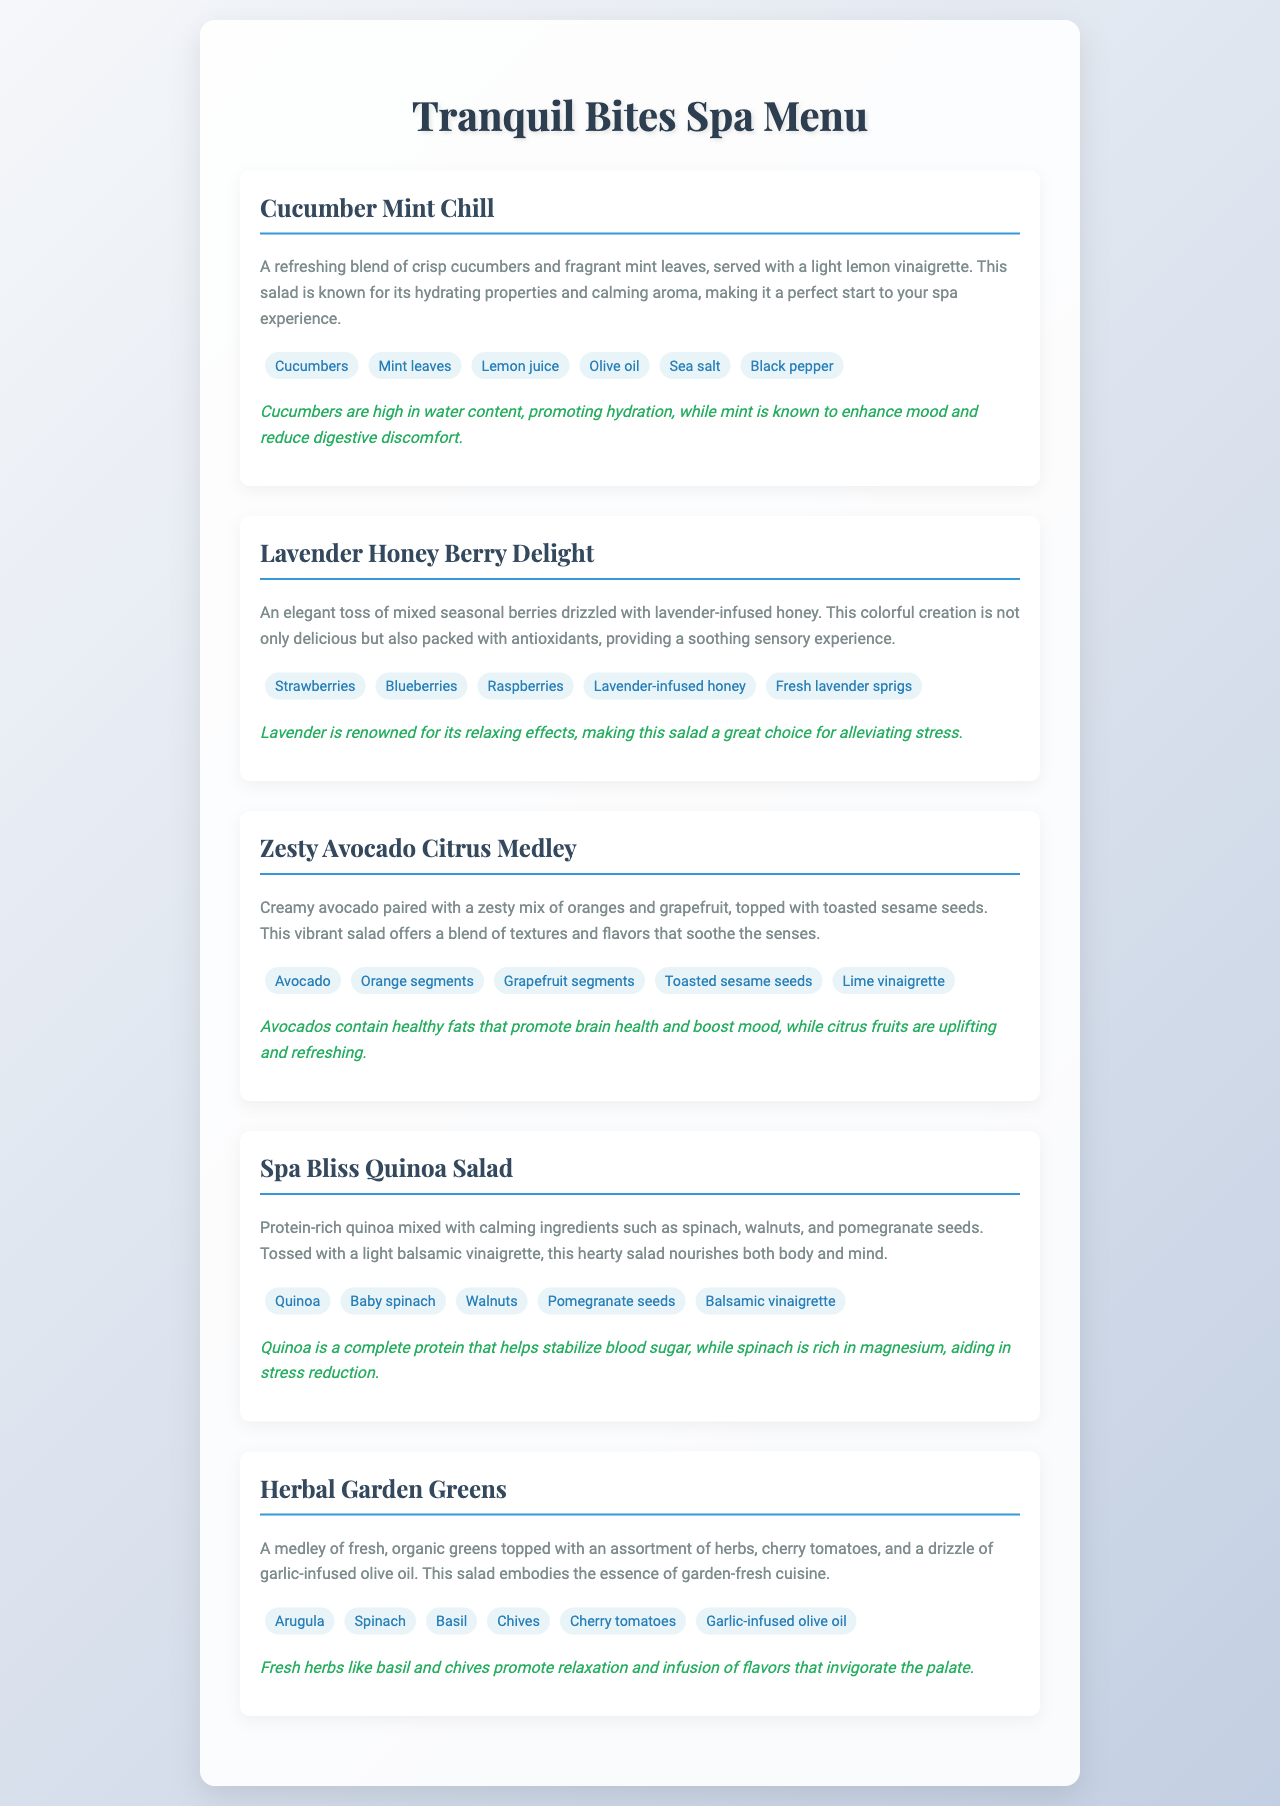What is the first salad listed on the menu? The first salad mentioned in the menu section is "Cucumber Mint Chill."
Answer: Cucumber Mint Chill How many ingredients are in the Lavender Honey Berry Delight? The ingredients listed for Lavender Honey Berry Delight include five items: strawberries, blueberries, raspberries, lavender-infused honey, and fresh lavender sprigs.
Answer: Five What ingredient is used in the Zesty Avocado Citrus Medley that adds textural variety? The Zesty Avocado Citrus Medley includes toasted sesame seeds, which contribute texture.
Answer: Toasted sesame seeds Which salad contains quinoa? The salad that includes quinoa is "Spa Bliss Quinoa Salad."
Answer: Spa Bliss Quinoa Salad What calming property is associated with cucumbers in the Cucumber Mint Chill? The document mentions that cucumbers promote hydration, which is their calming property.
Answer: Hydration What is the main flavoring herb in the Herbal Garden Greens? The main flavoring herb featured prominently in the Herbal Garden Greens is basil.
Answer: Basil What nutrient in spinach is noted for aiding in stress reduction? The document states that spinach is rich in magnesium, which helps in stress reduction.
Answer: Magnesium Which fruit in the Zesty Avocado Citrus Medley is specifically highlighted for its uplifting properties? The uplifting fruit highlighted in the Zesty Avocado Citrus Medley is citrus fruits, such as oranges and grapefruit.
Answer: Citrus fruits 